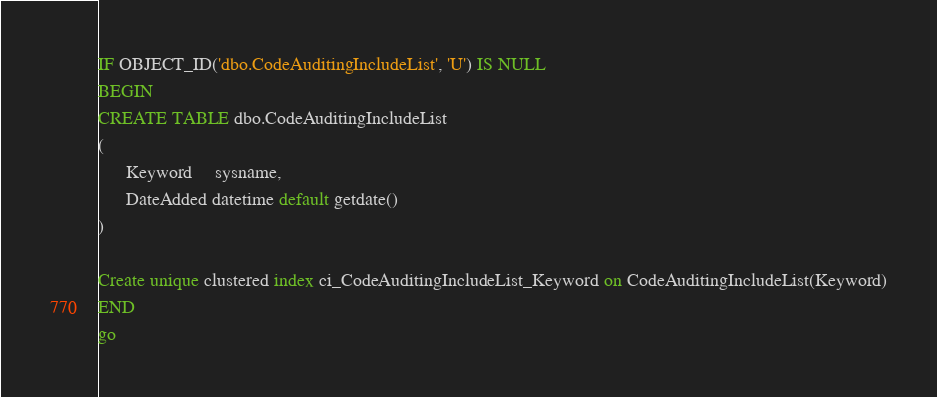Convert code to text. <code><loc_0><loc_0><loc_500><loc_500><_SQL_>IF OBJECT_ID('dbo.CodeAuditingIncludeList', 'U') IS NULL
BEGIN
CREATE TABLE dbo.CodeAuditingIncludeList
(
      Keyword     sysname,
      DateAdded datetime default getdate()
)

Create unique clustered index ci_CodeAuditingIncludeList_Keyword on CodeAuditingIncludeList(Keyword)
END
go
</code> 